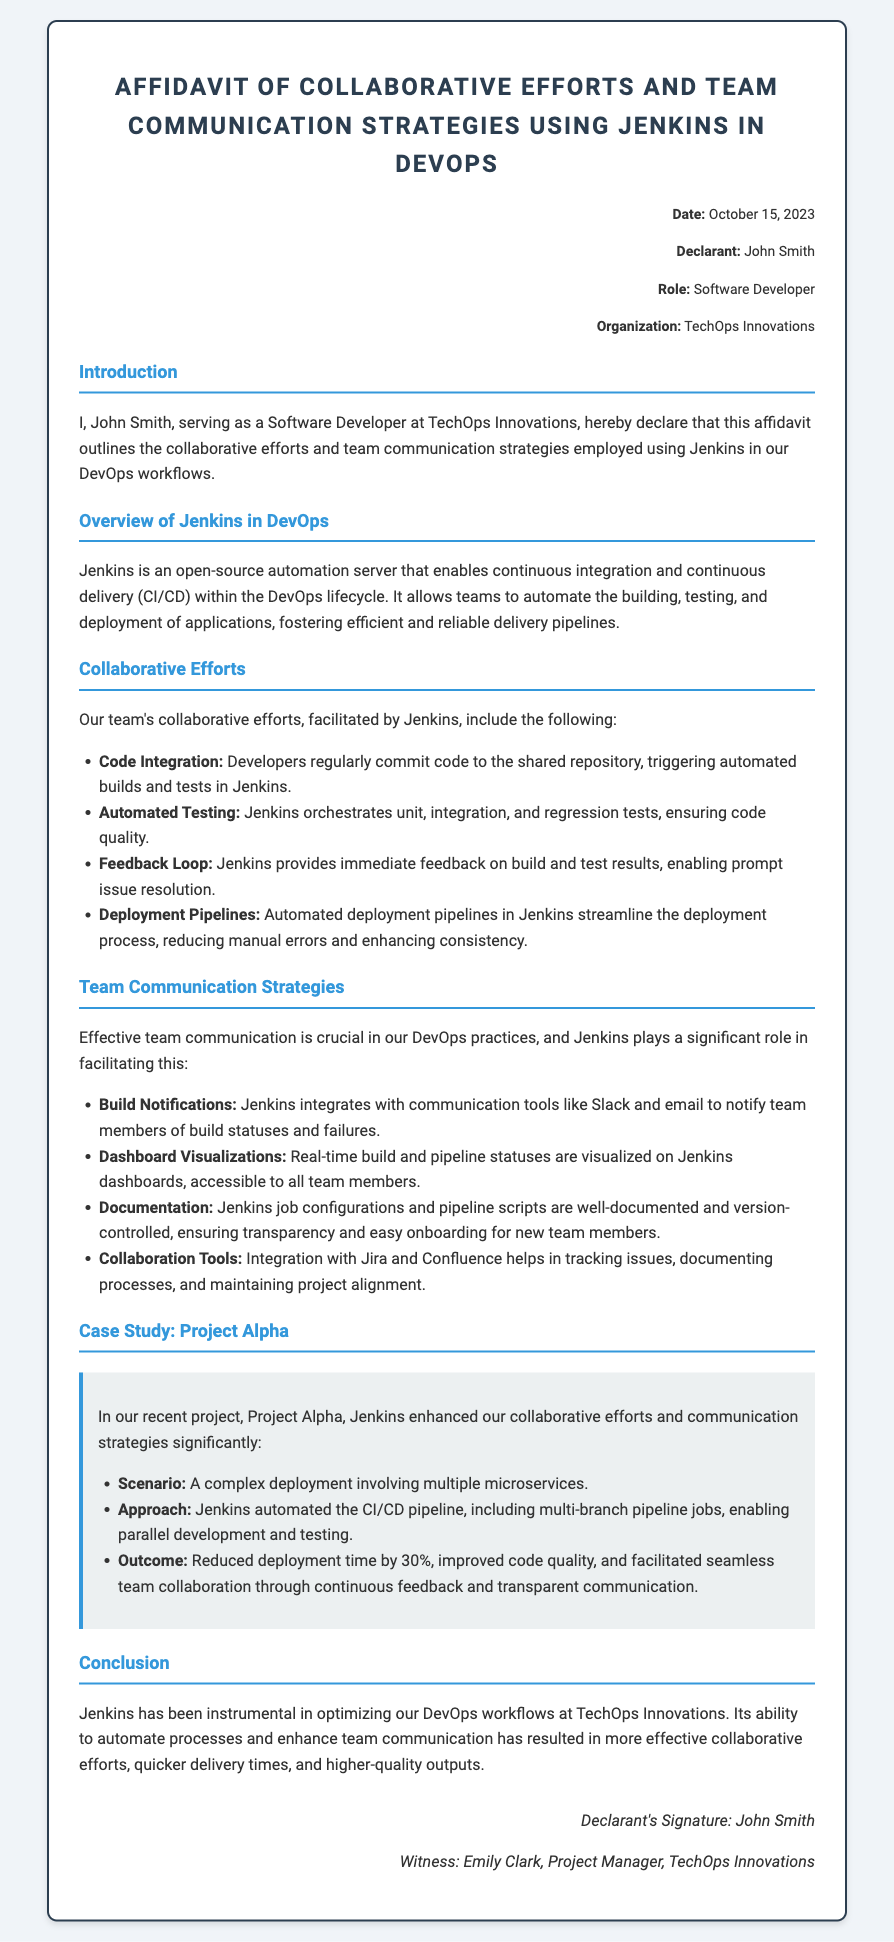What is the date of the affidavit? The date is stated in the header of the document.
Answer: October 15, 2023 Who is the declarant of the affidavit? The declarant's name is mentioned in the header section.
Answer: John Smith What organization does the declarant work for? The organization is indicated in the header of the affidavit.
Answer: TechOps Innovations What role does John Smith hold? John Smith's role is specified in the header of the document.
Answer: Software Developer What does Jenkins enable in DevOps? The document outlines Jenkins' role in the overview section.
Answer: Continuous integration and continuous delivery Which tools does Jenkins integrate with for build notifications? The document lists communication tools in the team communication strategies section.
Answer: Slack and email What was the outcome of Project Alpha? The outcome is described in the case study section.
Answer: Reduced deployment time by 30% What kind of tests does Jenkins orchestrate? The document mentions types of tests in the collaborative efforts section.
Answer: Unit, integration, and regression tests What does the declarant state about project alignment? The declarant mentions this in the team communication strategies section.
Answer: Collaboration Tools 